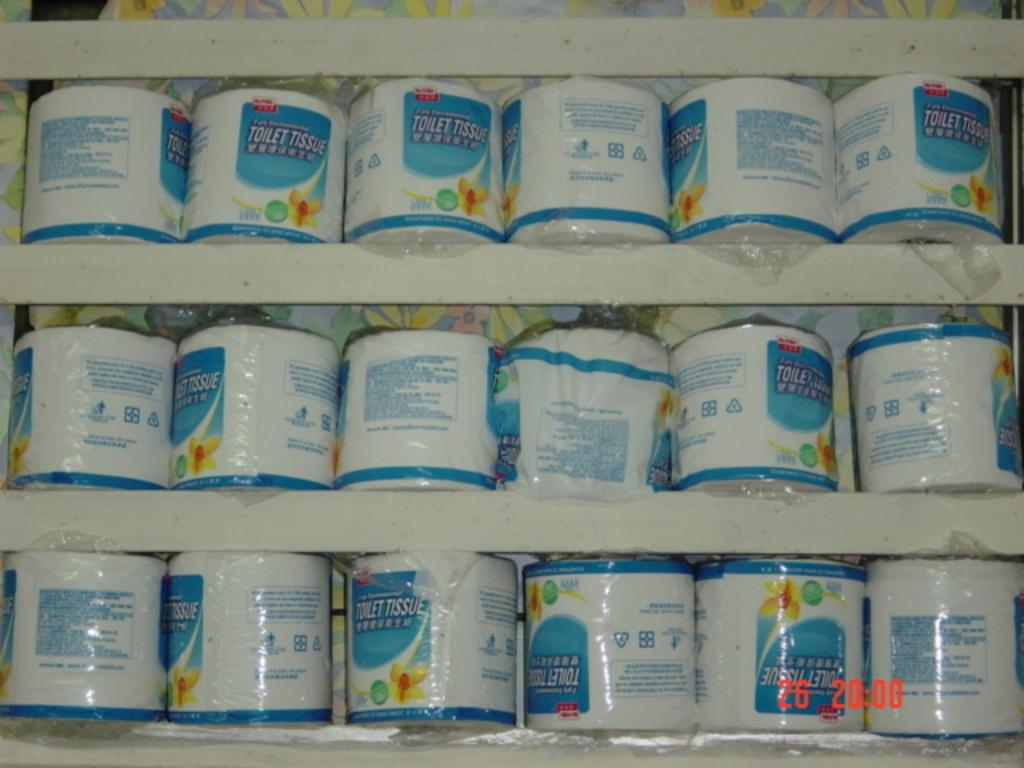Provide a one-sentence caption for the provided image. A selection of toilet tissue that was photographed at 20:00. 